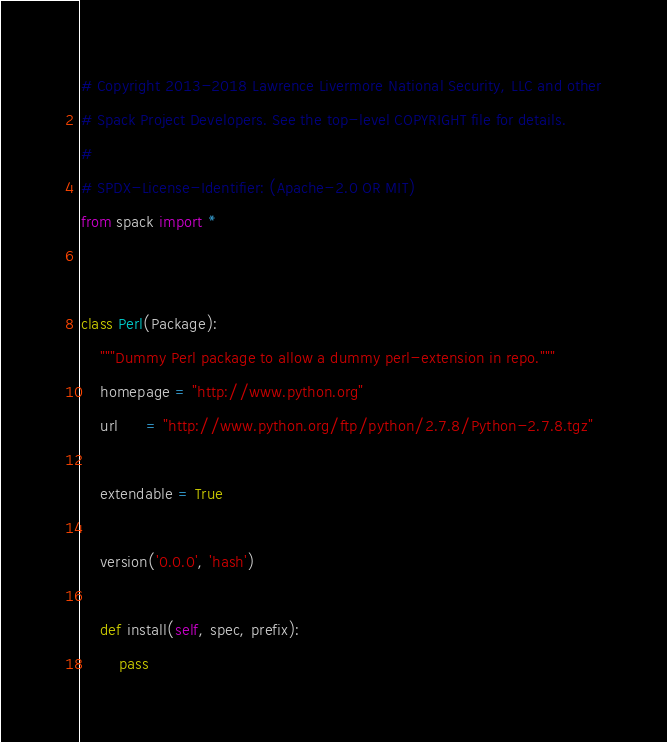<code> <loc_0><loc_0><loc_500><loc_500><_Python_># Copyright 2013-2018 Lawrence Livermore National Security, LLC and other
# Spack Project Developers. See the top-level COPYRIGHT file for details.
#
# SPDX-License-Identifier: (Apache-2.0 OR MIT)
from spack import *


class Perl(Package):
    """Dummy Perl package to allow a dummy perl-extension in repo."""
    homepage = "http://www.python.org"
    url      = "http://www.python.org/ftp/python/2.7.8/Python-2.7.8.tgz"

    extendable = True

    version('0.0.0', 'hash')

    def install(self, spec, prefix):
        pass
</code> 